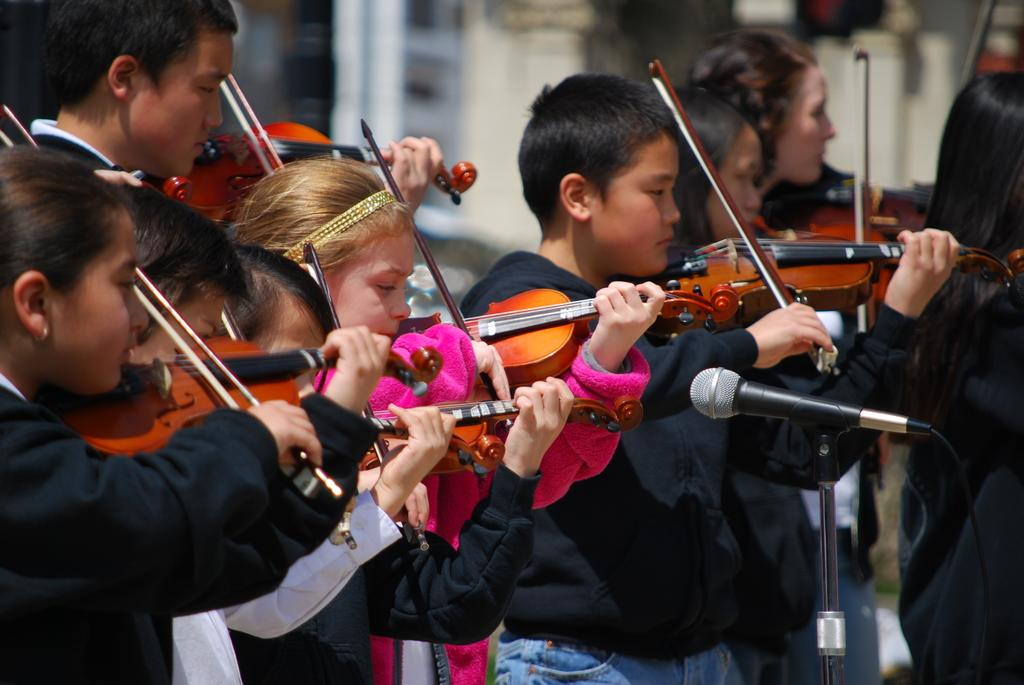What is happening in the image involving a group of people? In the image, a group of people are standing and playing musical instruments. What object is present in front of the people? There is a microphone with a stand in front of the people. What type of soup is being served in the image? There is no soup present in the image. 